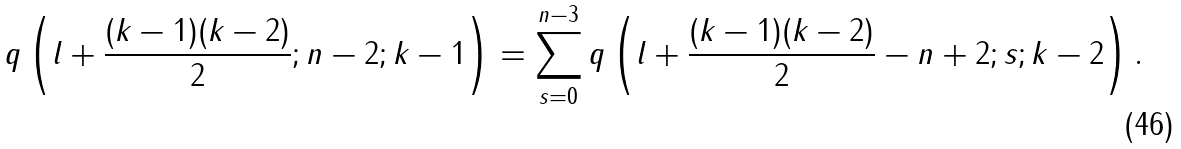Convert formula to latex. <formula><loc_0><loc_0><loc_500><loc_500>q \left ( l + \frac { ( k - 1 ) ( k - 2 ) } { 2 } ; n - 2 ; k - 1 \right ) = \sum _ { s = 0 } ^ { n - 3 } q \left ( l + \frac { ( k - 1 ) ( k - 2 ) } { 2 } - n + 2 ; s ; k - 2 \right ) .</formula> 